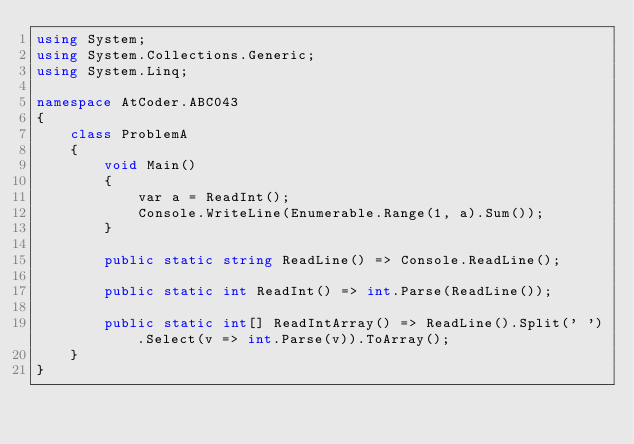Convert code to text. <code><loc_0><loc_0><loc_500><loc_500><_C#_>using System;
using System.Collections.Generic;
using System.Linq;

namespace AtCoder.ABC043
{
    class ProblemA
    {
        void Main()
        {
            var a = ReadInt();
            Console.WriteLine(Enumerable.Range(1, a).Sum());
        }

        public static string ReadLine() => Console.ReadLine();

        public static int ReadInt() => int.Parse(ReadLine());

        public static int[] ReadIntArray() => ReadLine().Split(' ').Select(v => int.Parse(v)).ToArray();
    }
}
</code> 